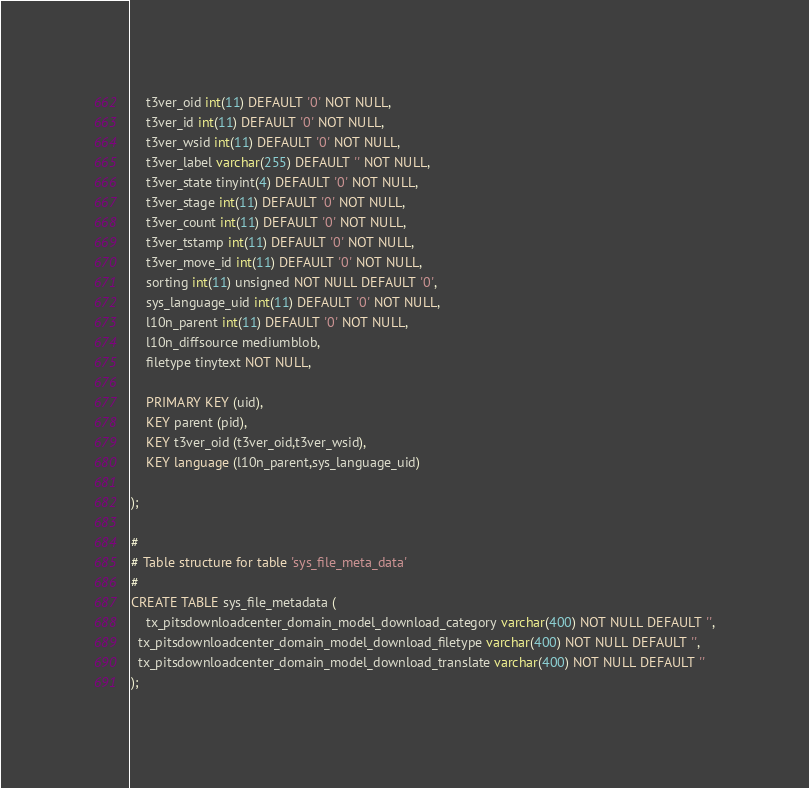Convert code to text. <code><loc_0><loc_0><loc_500><loc_500><_SQL_>	t3ver_oid int(11) DEFAULT '0' NOT NULL,
	t3ver_id int(11) DEFAULT '0' NOT NULL,
	t3ver_wsid int(11) DEFAULT '0' NOT NULL,
	t3ver_label varchar(255) DEFAULT '' NOT NULL,
	t3ver_state tinyint(4) DEFAULT '0' NOT NULL,
	t3ver_stage int(11) DEFAULT '0' NOT NULL,
	t3ver_count int(11) DEFAULT '0' NOT NULL,
	t3ver_tstamp int(11) DEFAULT '0' NOT NULL,
	t3ver_move_id int(11) DEFAULT '0' NOT NULL,
	sorting int(11) unsigned NOT NULL DEFAULT '0',
	sys_language_uid int(11) DEFAULT '0' NOT NULL,
	l10n_parent int(11) DEFAULT '0' NOT NULL,
	l10n_diffsource mediumblob,
	filetype tinytext NOT NULL,
	
	PRIMARY KEY (uid), 
	KEY parent (pid),
	KEY t3ver_oid (t3ver_oid,t3ver_wsid),
 	KEY language (l10n_parent,sys_language_uid)

);

#
# Table structure for table 'sys_file_meta_data'
#
CREATE TABLE sys_file_metadata (
	tx_pitsdownloadcenter_domain_model_download_category varchar(400) NOT NULL DEFAULT '',
  tx_pitsdownloadcenter_domain_model_download_filetype varchar(400) NOT NULL DEFAULT '',
  tx_pitsdownloadcenter_domain_model_download_translate varchar(400) NOT NULL DEFAULT ''
);

</code> 